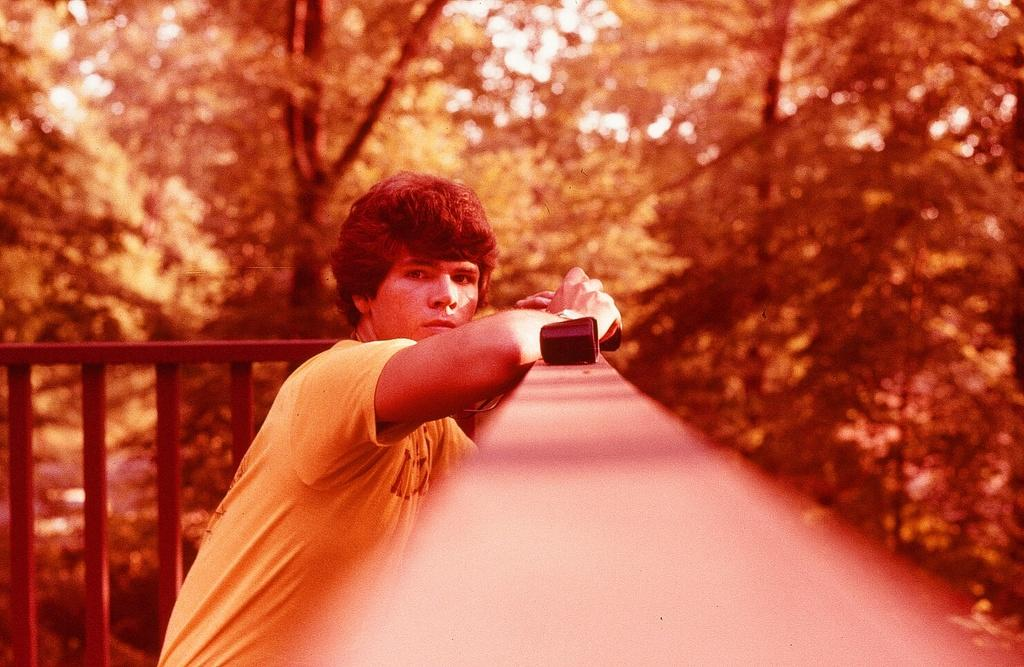What is the person in the image wearing? There is a person wearing a dress in the image. What can be seen in the background of the image? There is railing and many trees in the background of the image. How many apples are hanging from the trees in the image? There is no mention of apples in the image, so we cannot determine how many apples are hanging from the trees. 